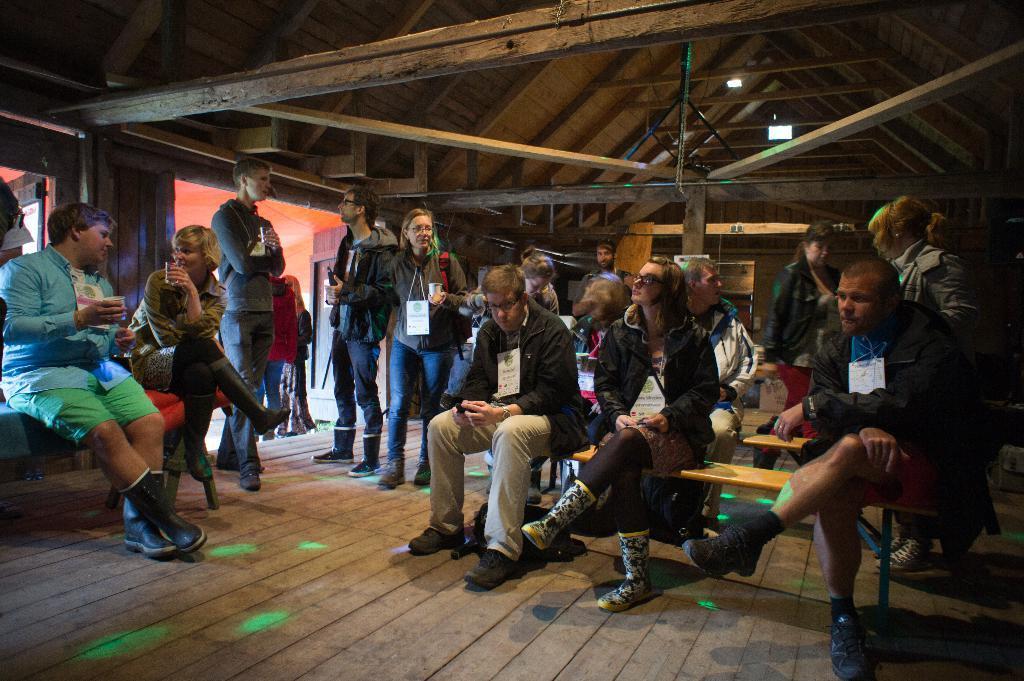Can you describe this image briefly? Inside a wooden room there are a group of people, they are discussing with each other and some of the people were standing at the entrance. 